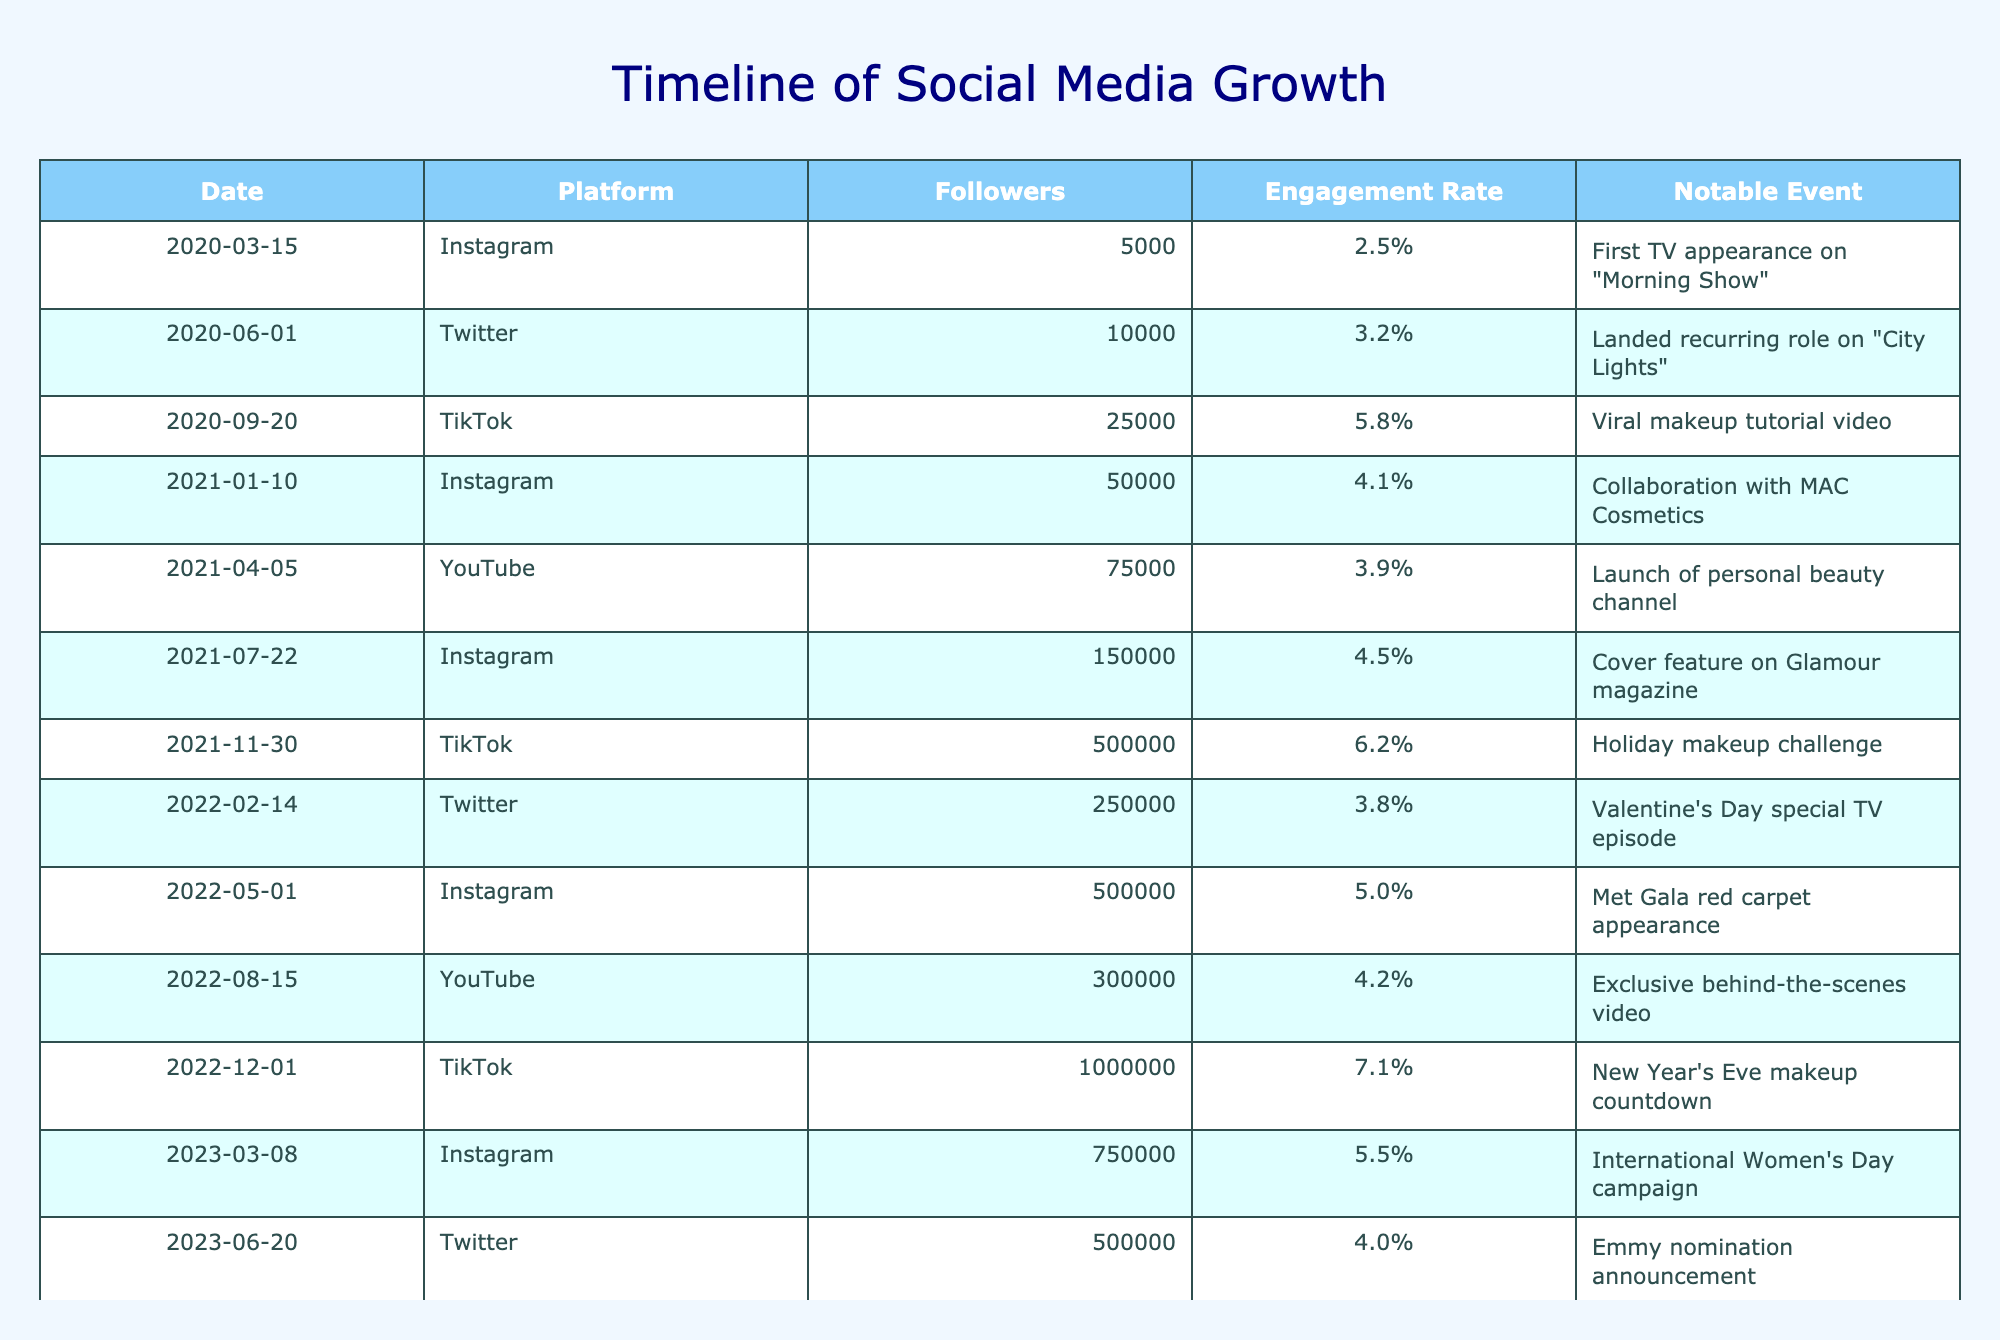What significant event occurred on June 1, 2020? According to the table, the notable event on June 1, 2020, is "Landed recurring role on 'City Lights'," making it a significant milestone in the career progression.
Answer: Landed recurring role on "City Lights" On which platform did engagement metrics peak in December 2022? The table shows that TikTok had the highest engagement rate at 7.1% in December 2022, which indicates it peaked in engagement metrics during that month.
Answer: TikTok What was the average engagement rate across all platforms in 2021? To calculate the average engagement rate for 2021, we add the engagement rates for that year (4.1%, 3.9%, 4.5%) and divide by the count of events (3). This results in an average engagement rate of (4.1 + 3.9 + 4.5) / 3 = 4.17%.
Answer: 4.17% Did the follower count increase from January to March 2023? By comparing the follower counts from January 2023 (750,000) to previous months, we see that it did increase since January was the last recorded month before March.
Answer: Yes Which platform had the largest increase in followers from the beginning to the end of the timeline? Examining the follower counts from the beginning with Instagram at 5,000 to TikTok in March 2023 at 1,000,000, we calculate the increase for each platform. The largest increase happened on TikTok, from 25,000 in September 2020 to 1,000,000 in December 2022, which is a difference of 975,000 followers.
Answer: TikTok 